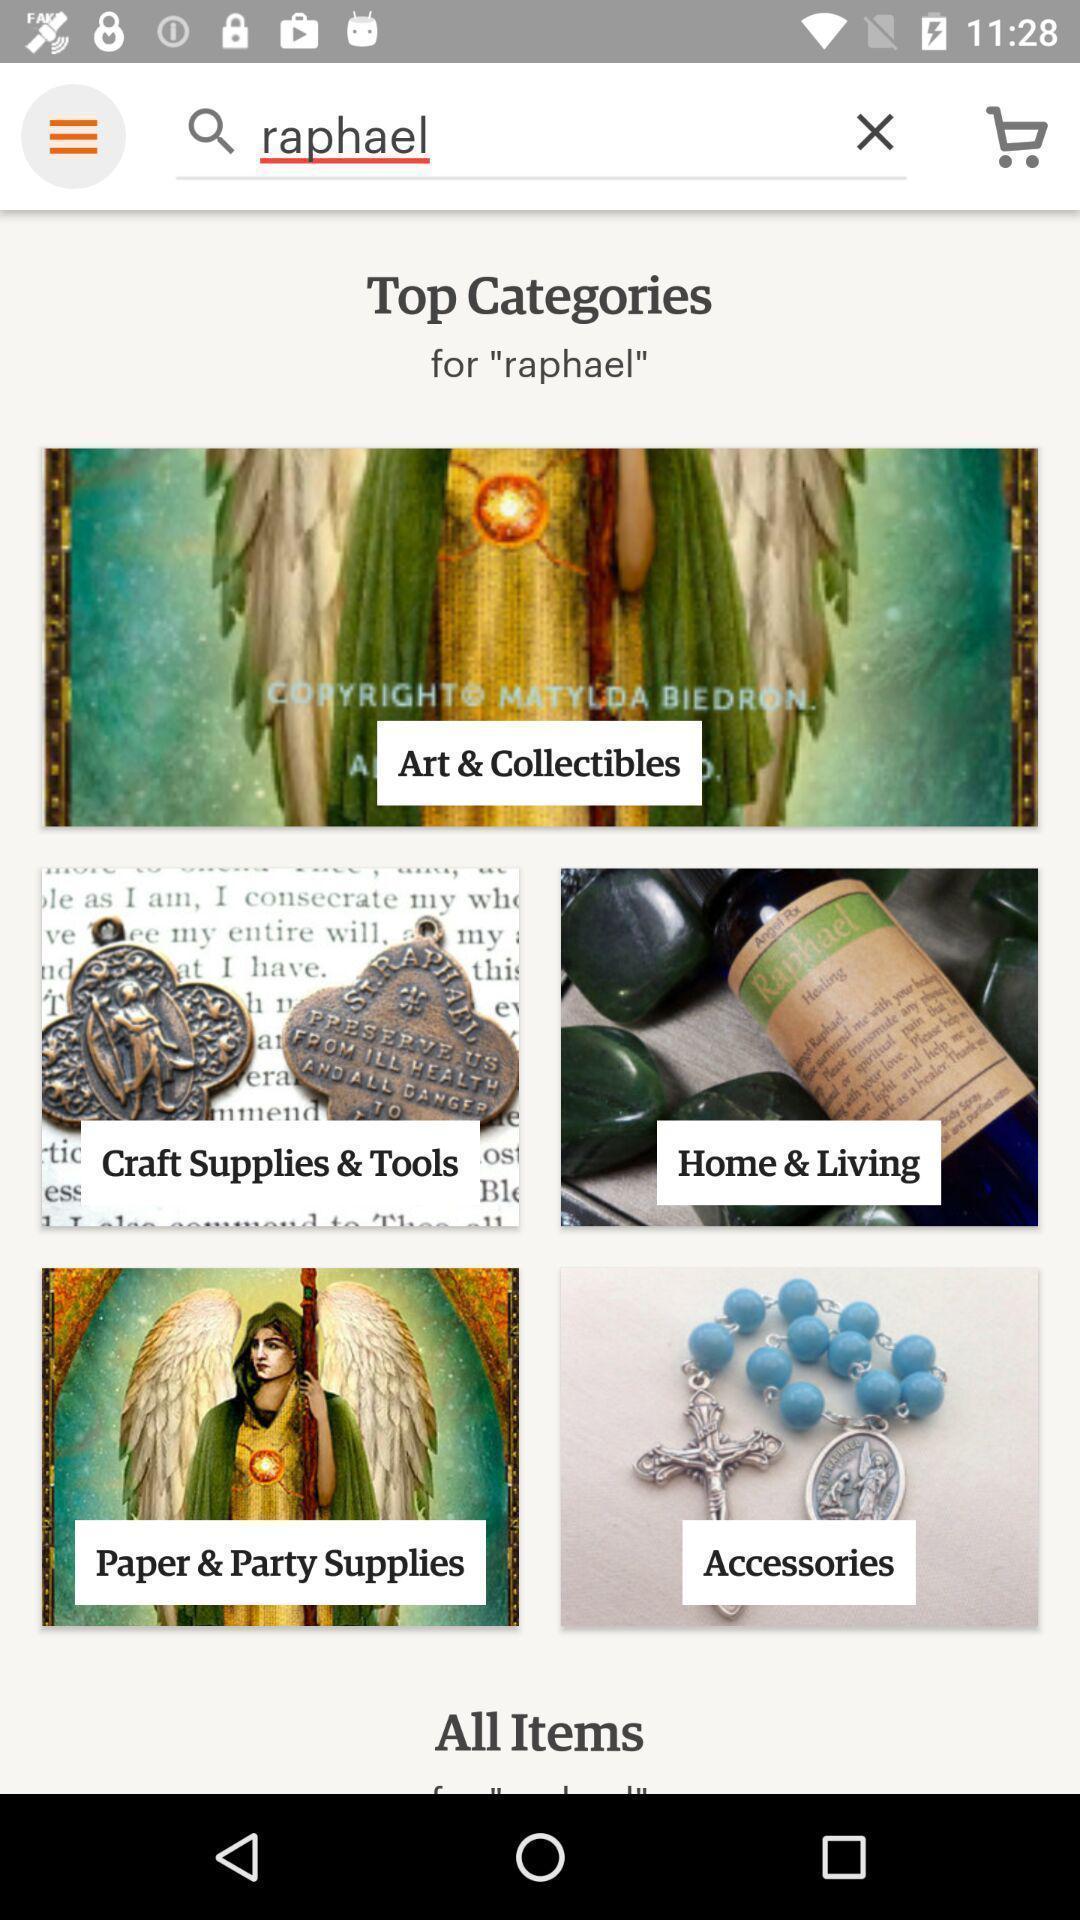Describe the visual elements of this screenshot. Search page of a shopping app. 